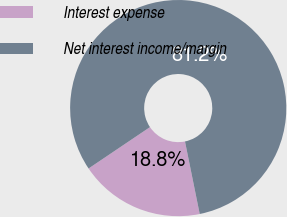Convert chart to OTSL. <chart><loc_0><loc_0><loc_500><loc_500><pie_chart><fcel>Interest expense<fcel>Net interest income/margin<nl><fcel>18.75%<fcel>81.25%<nl></chart> 